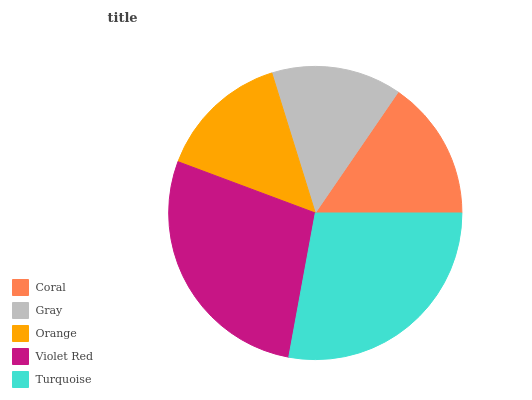Is Gray the minimum?
Answer yes or no. Yes. Is Turquoise the maximum?
Answer yes or no. Yes. Is Orange the minimum?
Answer yes or no. No. Is Orange the maximum?
Answer yes or no. No. Is Orange greater than Gray?
Answer yes or no. Yes. Is Gray less than Orange?
Answer yes or no. Yes. Is Gray greater than Orange?
Answer yes or no. No. Is Orange less than Gray?
Answer yes or no. No. Is Coral the high median?
Answer yes or no. Yes. Is Coral the low median?
Answer yes or no. Yes. Is Gray the high median?
Answer yes or no. No. Is Violet Red the low median?
Answer yes or no. No. 